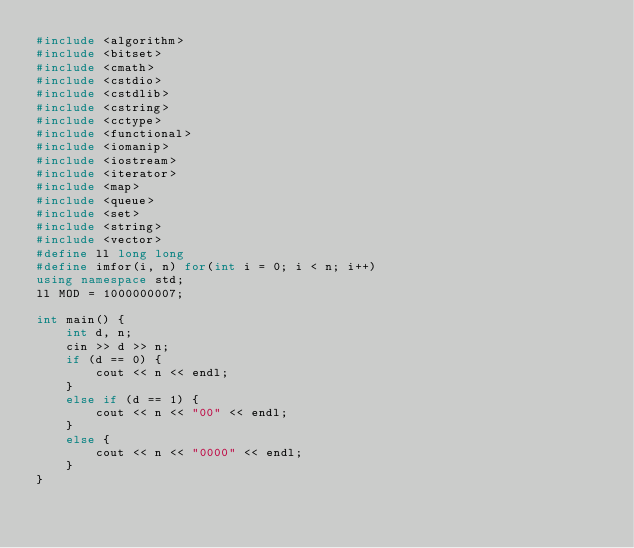Convert code to text. <code><loc_0><loc_0><loc_500><loc_500><_C++_>#include <algorithm>
#include <bitset>
#include <cmath>
#include <cstdio>
#include <cstdlib>
#include <cstring>
#include <cctype>
#include <functional>
#include <iomanip>
#include <iostream>
#include <iterator>
#include <map>
#include <queue>
#include <set>
#include <string>
#include <vector>
#define ll long long
#define imfor(i, n) for(int i = 0; i < n; i++)
using namespace std;
ll MOD = 1000000007;

int main() {
    int d, n;
    cin >> d >> n;
    if (d == 0) {
        cout << n << endl;
    }
    else if (d == 1) {
        cout << n << "00" << endl;
    }
    else {
        cout << n << "0000" << endl;
    }
}</code> 